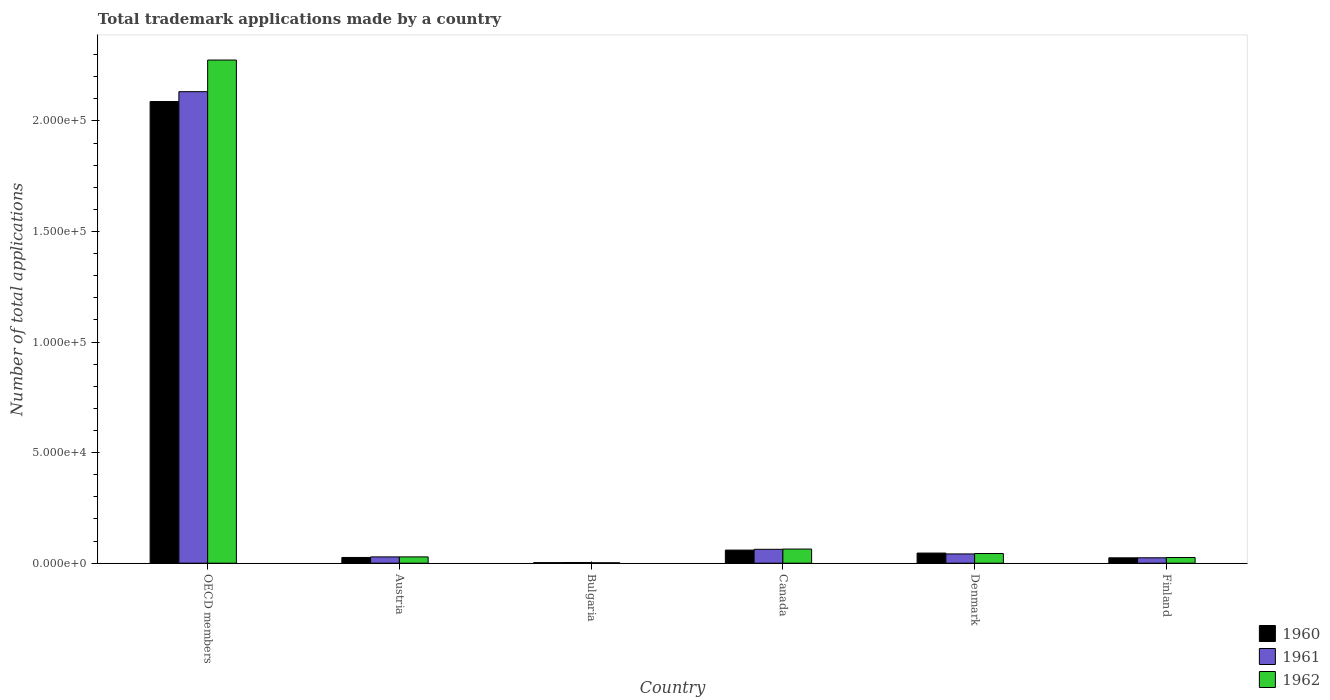How many different coloured bars are there?
Your response must be concise. 3. How many groups of bars are there?
Provide a short and direct response. 6. Are the number of bars per tick equal to the number of legend labels?
Your response must be concise. Yes. How many bars are there on the 6th tick from the left?
Provide a succinct answer. 3. What is the label of the 5th group of bars from the left?
Offer a very short reply. Denmark. What is the number of applications made by in 1962 in Finland?
Your answer should be compact. 2582. Across all countries, what is the maximum number of applications made by in 1962?
Give a very brief answer. 2.28e+05. Across all countries, what is the minimum number of applications made by in 1960?
Your answer should be very brief. 250. What is the total number of applications made by in 1961 in the graph?
Keep it short and to the point. 2.29e+05. What is the difference between the number of applications made by in 1962 in Austria and that in Finland?
Ensure brevity in your answer.  267. What is the difference between the number of applications made by in 1960 in Bulgaria and the number of applications made by in 1961 in Canada?
Give a very brief answer. -6031. What is the average number of applications made by in 1961 per country?
Provide a short and direct response. 3.82e+04. What is the difference between the number of applications made by of/in 1962 and number of applications made by of/in 1960 in Austria?
Your response must be concise. 253. In how many countries, is the number of applications made by in 1962 greater than 120000?
Provide a succinct answer. 1. What is the ratio of the number of applications made by in 1962 in Austria to that in Canada?
Your answer should be compact. 0.45. Is the number of applications made by in 1961 in Denmark less than that in OECD members?
Provide a short and direct response. Yes. Is the difference between the number of applications made by in 1962 in Canada and Denmark greater than the difference between the number of applications made by in 1960 in Canada and Denmark?
Ensure brevity in your answer.  Yes. What is the difference between the highest and the second highest number of applications made by in 1961?
Provide a succinct answer. 2085. What is the difference between the highest and the lowest number of applications made by in 1961?
Offer a very short reply. 2.13e+05. In how many countries, is the number of applications made by in 1960 greater than the average number of applications made by in 1960 taken over all countries?
Offer a terse response. 1. What does the 2nd bar from the left in Finland represents?
Offer a terse response. 1961. What does the 3rd bar from the right in Canada represents?
Provide a succinct answer. 1960. Is it the case that in every country, the sum of the number of applications made by in 1960 and number of applications made by in 1962 is greater than the number of applications made by in 1961?
Give a very brief answer. Yes. How many bars are there?
Provide a short and direct response. 18. How many countries are there in the graph?
Offer a terse response. 6. Does the graph contain any zero values?
Ensure brevity in your answer.  No. Where does the legend appear in the graph?
Your answer should be compact. Bottom right. How are the legend labels stacked?
Keep it short and to the point. Vertical. What is the title of the graph?
Provide a succinct answer. Total trademark applications made by a country. Does "1998" appear as one of the legend labels in the graph?
Offer a terse response. No. What is the label or title of the Y-axis?
Offer a very short reply. Number of total applications. What is the Number of total applications of 1960 in OECD members?
Offer a very short reply. 2.09e+05. What is the Number of total applications in 1961 in OECD members?
Ensure brevity in your answer.  2.13e+05. What is the Number of total applications in 1962 in OECD members?
Your answer should be compact. 2.28e+05. What is the Number of total applications in 1960 in Austria?
Your answer should be compact. 2596. What is the Number of total applications of 1961 in Austria?
Provide a short and direct response. 2852. What is the Number of total applications of 1962 in Austria?
Offer a terse response. 2849. What is the Number of total applications of 1960 in Bulgaria?
Your answer should be very brief. 250. What is the Number of total applications in 1961 in Bulgaria?
Your response must be concise. 318. What is the Number of total applications of 1962 in Bulgaria?
Ensure brevity in your answer.  195. What is the Number of total applications in 1960 in Canada?
Provide a short and direct response. 5927. What is the Number of total applications of 1961 in Canada?
Offer a terse response. 6281. What is the Number of total applications in 1962 in Canada?
Provide a succinct answer. 6395. What is the Number of total applications in 1960 in Denmark?
Offer a very short reply. 4584. What is the Number of total applications in 1961 in Denmark?
Provide a short and direct response. 4196. What is the Number of total applications in 1962 in Denmark?
Offer a terse response. 4380. What is the Number of total applications in 1960 in Finland?
Provide a short and direct response. 2432. What is the Number of total applications in 1961 in Finland?
Your response must be concise. 2450. What is the Number of total applications of 1962 in Finland?
Your answer should be compact. 2582. Across all countries, what is the maximum Number of total applications in 1960?
Your response must be concise. 2.09e+05. Across all countries, what is the maximum Number of total applications in 1961?
Provide a short and direct response. 2.13e+05. Across all countries, what is the maximum Number of total applications in 1962?
Keep it short and to the point. 2.28e+05. Across all countries, what is the minimum Number of total applications of 1960?
Your response must be concise. 250. Across all countries, what is the minimum Number of total applications in 1961?
Provide a short and direct response. 318. Across all countries, what is the minimum Number of total applications of 1962?
Your answer should be compact. 195. What is the total Number of total applications of 1960 in the graph?
Offer a terse response. 2.25e+05. What is the total Number of total applications of 1961 in the graph?
Offer a very short reply. 2.29e+05. What is the total Number of total applications in 1962 in the graph?
Provide a succinct answer. 2.44e+05. What is the difference between the Number of total applications of 1960 in OECD members and that in Austria?
Give a very brief answer. 2.06e+05. What is the difference between the Number of total applications in 1961 in OECD members and that in Austria?
Offer a very short reply. 2.10e+05. What is the difference between the Number of total applications of 1962 in OECD members and that in Austria?
Make the answer very short. 2.25e+05. What is the difference between the Number of total applications in 1960 in OECD members and that in Bulgaria?
Give a very brief answer. 2.09e+05. What is the difference between the Number of total applications in 1961 in OECD members and that in Bulgaria?
Offer a terse response. 2.13e+05. What is the difference between the Number of total applications in 1962 in OECD members and that in Bulgaria?
Offer a very short reply. 2.27e+05. What is the difference between the Number of total applications of 1960 in OECD members and that in Canada?
Your answer should be compact. 2.03e+05. What is the difference between the Number of total applications of 1961 in OECD members and that in Canada?
Ensure brevity in your answer.  2.07e+05. What is the difference between the Number of total applications in 1962 in OECD members and that in Canada?
Your answer should be very brief. 2.21e+05. What is the difference between the Number of total applications in 1960 in OECD members and that in Denmark?
Provide a succinct answer. 2.04e+05. What is the difference between the Number of total applications in 1961 in OECD members and that in Denmark?
Provide a short and direct response. 2.09e+05. What is the difference between the Number of total applications in 1962 in OECD members and that in Denmark?
Ensure brevity in your answer.  2.23e+05. What is the difference between the Number of total applications of 1960 in OECD members and that in Finland?
Keep it short and to the point. 2.06e+05. What is the difference between the Number of total applications of 1961 in OECD members and that in Finland?
Your response must be concise. 2.11e+05. What is the difference between the Number of total applications of 1962 in OECD members and that in Finland?
Offer a very short reply. 2.25e+05. What is the difference between the Number of total applications in 1960 in Austria and that in Bulgaria?
Offer a very short reply. 2346. What is the difference between the Number of total applications of 1961 in Austria and that in Bulgaria?
Ensure brevity in your answer.  2534. What is the difference between the Number of total applications of 1962 in Austria and that in Bulgaria?
Make the answer very short. 2654. What is the difference between the Number of total applications in 1960 in Austria and that in Canada?
Ensure brevity in your answer.  -3331. What is the difference between the Number of total applications in 1961 in Austria and that in Canada?
Ensure brevity in your answer.  -3429. What is the difference between the Number of total applications in 1962 in Austria and that in Canada?
Keep it short and to the point. -3546. What is the difference between the Number of total applications in 1960 in Austria and that in Denmark?
Provide a short and direct response. -1988. What is the difference between the Number of total applications in 1961 in Austria and that in Denmark?
Ensure brevity in your answer.  -1344. What is the difference between the Number of total applications in 1962 in Austria and that in Denmark?
Offer a very short reply. -1531. What is the difference between the Number of total applications in 1960 in Austria and that in Finland?
Offer a terse response. 164. What is the difference between the Number of total applications in 1961 in Austria and that in Finland?
Provide a succinct answer. 402. What is the difference between the Number of total applications in 1962 in Austria and that in Finland?
Your answer should be very brief. 267. What is the difference between the Number of total applications in 1960 in Bulgaria and that in Canada?
Provide a short and direct response. -5677. What is the difference between the Number of total applications of 1961 in Bulgaria and that in Canada?
Provide a succinct answer. -5963. What is the difference between the Number of total applications in 1962 in Bulgaria and that in Canada?
Provide a succinct answer. -6200. What is the difference between the Number of total applications in 1960 in Bulgaria and that in Denmark?
Make the answer very short. -4334. What is the difference between the Number of total applications in 1961 in Bulgaria and that in Denmark?
Provide a short and direct response. -3878. What is the difference between the Number of total applications of 1962 in Bulgaria and that in Denmark?
Provide a short and direct response. -4185. What is the difference between the Number of total applications of 1960 in Bulgaria and that in Finland?
Provide a short and direct response. -2182. What is the difference between the Number of total applications in 1961 in Bulgaria and that in Finland?
Make the answer very short. -2132. What is the difference between the Number of total applications in 1962 in Bulgaria and that in Finland?
Your answer should be compact. -2387. What is the difference between the Number of total applications in 1960 in Canada and that in Denmark?
Give a very brief answer. 1343. What is the difference between the Number of total applications in 1961 in Canada and that in Denmark?
Make the answer very short. 2085. What is the difference between the Number of total applications of 1962 in Canada and that in Denmark?
Provide a succinct answer. 2015. What is the difference between the Number of total applications in 1960 in Canada and that in Finland?
Provide a succinct answer. 3495. What is the difference between the Number of total applications in 1961 in Canada and that in Finland?
Make the answer very short. 3831. What is the difference between the Number of total applications in 1962 in Canada and that in Finland?
Make the answer very short. 3813. What is the difference between the Number of total applications in 1960 in Denmark and that in Finland?
Give a very brief answer. 2152. What is the difference between the Number of total applications in 1961 in Denmark and that in Finland?
Provide a succinct answer. 1746. What is the difference between the Number of total applications of 1962 in Denmark and that in Finland?
Ensure brevity in your answer.  1798. What is the difference between the Number of total applications of 1960 in OECD members and the Number of total applications of 1961 in Austria?
Your response must be concise. 2.06e+05. What is the difference between the Number of total applications in 1960 in OECD members and the Number of total applications in 1962 in Austria?
Ensure brevity in your answer.  2.06e+05. What is the difference between the Number of total applications of 1961 in OECD members and the Number of total applications of 1962 in Austria?
Your response must be concise. 2.10e+05. What is the difference between the Number of total applications of 1960 in OECD members and the Number of total applications of 1961 in Bulgaria?
Offer a very short reply. 2.08e+05. What is the difference between the Number of total applications of 1960 in OECD members and the Number of total applications of 1962 in Bulgaria?
Offer a terse response. 2.09e+05. What is the difference between the Number of total applications of 1961 in OECD members and the Number of total applications of 1962 in Bulgaria?
Provide a short and direct response. 2.13e+05. What is the difference between the Number of total applications of 1960 in OECD members and the Number of total applications of 1961 in Canada?
Your answer should be very brief. 2.02e+05. What is the difference between the Number of total applications of 1960 in OECD members and the Number of total applications of 1962 in Canada?
Provide a succinct answer. 2.02e+05. What is the difference between the Number of total applications of 1961 in OECD members and the Number of total applications of 1962 in Canada?
Offer a terse response. 2.07e+05. What is the difference between the Number of total applications of 1960 in OECD members and the Number of total applications of 1961 in Denmark?
Provide a short and direct response. 2.05e+05. What is the difference between the Number of total applications of 1960 in OECD members and the Number of total applications of 1962 in Denmark?
Keep it short and to the point. 2.04e+05. What is the difference between the Number of total applications in 1961 in OECD members and the Number of total applications in 1962 in Denmark?
Offer a terse response. 2.09e+05. What is the difference between the Number of total applications in 1960 in OECD members and the Number of total applications in 1961 in Finland?
Give a very brief answer. 2.06e+05. What is the difference between the Number of total applications in 1960 in OECD members and the Number of total applications in 1962 in Finland?
Offer a terse response. 2.06e+05. What is the difference between the Number of total applications of 1961 in OECD members and the Number of total applications of 1962 in Finland?
Keep it short and to the point. 2.11e+05. What is the difference between the Number of total applications of 1960 in Austria and the Number of total applications of 1961 in Bulgaria?
Offer a terse response. 2278. What is the difference between the Number of total applications in 1960 in Austria and the Number of total applications in 1962 in Bulgaria?
Make the answer very short. 2401. What is the difference between the Number of total applications of 1961 in Austria and the Number of total applications of 1962 in Bulgaria?
Offer a very short reply. 2657. What is the difference between the Number of total applications of 1960 in Austria and the Number of total applications of 1961 in Canada?
Your answer should be very brief. -3685. What is the difference between the Number of total applications of 1960 in Austria and the Number of total applications of 1962 in Canada?
Ensure brevity in your answer.  -3799. What is the difference between the Number of total applications in 1961 in Austria and the Number of total applications in 1962 in Canada?
Provide a succinct answer. -3543. What is the difference between the Number of total applications of 1960 in Austria and the Number of total applications of 1961 in Denmark?
Keep it short and to the point. -1600. What is the difference between the Number of total applications in 1960 in Austria and the Number of total applications in 1962 in Denmark?
Keep it short and to the point. -1784. What is the difference between the Number of total applications of 1961 in Austria and the Number of total applications of 1962 in Denmark?
Keep it short and to the point. -1528. What is the difference between the Number of total applications of 1960 in Austria and the Number of total applications of 1961 in Finland?
Provide a succinct answer. 146. What is the difference between the Number of total applications of 1961 in Austria and the Number of total applications of 1962 in Finland?
Offer a terse response. 270. What is the difference between the Number of total applications of 1960 in Bulgaria and the Number of total applications of 1961 in Canada?
Your answer should be compact. -6031. What is the difference between the Number of total applications of 1960 in Bulgaria and the Number of total applications of 1962 in Canada?
Provide a succinct answer. -6145. What is the difference between the Number of total applications in 1961 in Bulgaria and the Number of total applications in 1962 in Canada?
Offer a terse response. -6077. What is the difference between the Number of total applications in 1960 in Bulgaria and the Number of total applications in 1961 in Denmark?
Give a very brief answer. -3946. What is the difference between the Number of total applications in 1960 in Bulgaria and the Number of total applications in 1962 in Denmark?
Offer a terse response. -4130. What is the difference between the Number of total applications in 1961 in Bulgaria and the Number of total applications in 1962 in Denmark?
Offer a very short reply. -4062. What is the difference between the Number of total applications of 1960 in Bulgaria and the Number of total applications of 1961 in Finland?
Provide a succinct answer. -2200. What is the difference between the Number of total applications in 1960 in Bulgaria and the Number of total applications in 1962 in Finland?
Give a very brief answer. -2332. What is the difference between the Number of total applications in 1961 in Bulgaria and the Number of total applications in 1962 in Finland?
Your answer should be very brief. -2264. What is the difference between the Number of total applications of 1960 in Canada and the Number of total applications of 1961 in Denmark?
Your response must be concise. 1731. What is the difference between the Number of total applications in 1960 in Canada and the Number of total applications in 1962 in Denmark?
Your answer should be compact. 1547. What is the difference between the Number of total applications of 1961 in Canada and the Number of total applications of 1962 in Denmark?
Keep it short and to the point. 1901. What is the difference between the Number of total applications in 1960 in Canada and the Number of total applications in 1961 in Finland?
Keep it short and to the point. 3477. What is the difference between the Number of total applications of 1960 in Canada and the Number of total applications of 1962 in Finland?
Give a very brief answer. 3345. What is the difference between the Number of total applications in 1961 in Canada and the Number of total applications in 1962 in Finland?
Your answer should be very brief. 3699. What is the difference between the Number of total applications in 1960 in Denmark and the Number of total applications in 1961 in Finland?
Offer a very short reply. 2134. What is the difference between the Number of total applications in 1960 in Denmark and the Number of total applications in 1962 in Finland?
Provide a succinct answer. 2002. What is the difference between the Number of total applications in 1961 in Denmark and the Number of total applications in 1962 in Finland?
Give a very brief answer. 1614. What is the average Number of total applications of 1960 per country?
Ensure brevity in your answer.  3.74e+04. What is the average Number of total applications of 1961 per country?
Your answer should be compact. 3.82e+04. What is the average Number of total applications in 1962 per country?
Offer a terse response. 4.07e+04. What is the difference between the Number of total applications in 1960 and Number of total applications in 1961 in OECD members?
Your response must be concise. -4452. What is the difference between the Number of total applications in 1960 and Number of total applications in 1962 in OECD members?
Provide a short and direct response. -1.88e+04. What is the difference between the Number of total applications of 1961 and Number of total applications of 1962 in OECD members?
Ensure brevity in your answer.  -1.43e+04. What is the difference between the Number of total applications in 1960 and Number of total applications in 1961 in Austria?
Ensure brevity in your answer.  -256. What is the difference between the Number of total applications of 1960 and Number of total applications of 1962 in Austria?
Provide a short and direct response. -253. What is the difference between the Number of total applications of 1960 and Number of total applications of 1961 in Bulgaria?
Ensure brevity in your answer.  -68. What is the difference between the Number of total applications of 1960 and Number of total applications of 1962 in Bulgaria?
Provide a short and direct response. 55. What is the difference between the Number of total applications of 1961 and Number of total applications of 1962 in Bulgaria?
Offer a very short reply. 123. What is the difference between the Number of total applications in 1960 and Number of total applications in 1961 in Canada?
Your response must be concise. -354. What is the difference between the Number of total applications of 1960 and Number of total applications of 1962 in Canada?
Your response must be concise. -468. What is the difference between the Number of total applications in 1961 and Number of total applications in 1962 in Canada?
Offer a very short reply. -114. What is the difference between the Number of total applications in 1960 and Number of total applications in 1961 in Denmark?
Offer a very short reply. 388. What is the difference between the Number of total applications of 1960 and Number of total applications of 1962 in Denmark?
Make the answer very short. 204. What is the difference between the Number of total applications of 1961 and Number of total applications of 1962 in Denmark?
Keep it short and to the point. -184. What is the difference between the Number of total applications in 1960 and Number of total applications in 1961 in Finland?
Offer a terse response. -18. What is the difference between the Number of total applications in 1960 and Number of total applications in 1962 in Finland?
Make the answer very short. -150. What is the difference between the Number of total applications in 1961 and Number of total applications in 1962 in Finland?
Offer a very short reply. -132. What is the ratio of the Number of total applications of 1960 in OECD members to that in Austria?
Ensure brevity in your answer.  80.42. What is the ratio of the Number of total applications in 1961 in OECD members to that in Austria?
Ensure brevity in your answer.  74.76. What is the ratio of the Number of total applications in 1962 in OECD members to that in Austria?
Provide a short and direct response. 79.86. What is the ratio of the Number of total applications of 1960 in OECD members to that in Bulgaria?
Your answer should be very brief. 835.08. What is the ratio of the Number of total applications of 1961 in OECD members to that in Bulgaria?
Your answer should be compact. 670.51. What is the ratio of the Number of total applications in 1962 in OECD members to that in Bulgaria?
Keep it short and to the point. 1166.82. What is the ratio of the Number of total applications of 1960 in OECD members to that in Canada?
Provide a succinct answer. 35.22. What is the ratio of the Number of total applications of 1961 in OECD members to that in Canada?
Offer a very short reply. 33.95. What is the ratio of the Number of total applications in 1962 in OECD members to that in Canada?
Give a very brief answer. 35.58. What is the ratio of the Number of total applications of 1960 in OECD members to that in Denmark?
Keep it short and to the point. 45.54. What is the ratio of the Number of total applications in 1961 in OECD members to that in Denmark?
Ensure brevity in your answer.  50.82. What is the ratio of the Number of total applications in 1962 in OECD members to that in Denmark?
Your answer should be compact. 51.95. What is the ratio of the Number of total applications in 1960 in OECD members to that in Finland?
Your answer should be compact. 85.84. What is the ratio of the Number of total applications of 1961 in OECD members to that in Finland?
Your answer should be compact. 87.03. What is the ratio of the Number of total applications of 1962 in OECD members to that in Finland?
Your answer should be compact. 88.12. What is the ratio of the Number of total applications in 1960 in Austria to that in Bulgaria?
Offer a very short reply. 10.38. What is the ratio of the Number of total applications of 1961 in Austria to that in Bulgaria?
Give a very brief answer. 8.97. What is the ratio of the Number of total applications of 1962 in Austria to that in Bulgaria?
Keep it short and to the point. 14.61. What is the ratio of the Number of total applications in 1960 in Austria to that in Canada?
Provide a succinct answer. 0.44. What is the ratio of the Number of total applications in 1961 in Austria to that in Canada?
Provide a short and direct response. 0.45. What is the ratio of the Number of total applications in 1962 in Austria to that in Canada?
Make the answer very short. 0.45. What is the ratio of the Number of total applications in 1960 in Austria to that in Denmark?
Offer a very short reply. 0.57. What is the ratio of the Number of total applications of 1961 in Austria to that in Denmark?
Provide a succinct answer. 0.68. What is the ratio of the Number of total applications of 1962 in Austria to that in Denmark?
Keep it short and to the point. 0.65. What is the ratio of the Number of total applications in 1960 in Austria to that in Finland?
Make the answer very short. 1.07. What is the ratio of the Number of total applications in 1961 in Austria to that in Finland?
Offer a very short reply. 1.16. What is the ratio of the Number of total applications of 1962 in Austria to that in Finland?
Offer a very short reply. 1.1. What is the ratio of the Number of total applications of 1960 in Bulgaria to that in Canada?
Your response must be concise. 0.04. What is the ratio of the Number of total applications in 1961 in Bulgaria to that in Canada?
Offer a terse response. 0.05. What is the ratio of the Number of total applications in 1962 in Bulgaria to that in Canada?
Your answer should be compact. 0.03. What is the ratio of the Number of total applications in 1960 in Bulgaria to that in Denmark?
Ensure brevity in your answer.  0.05. What is the ratio of the Number of total applications in 1961 in Bulgaria to that in Denmark?
Ensure brevity in your answer.  0.08. What is the ratio of the Number of total applications of 1962 in Bulgaria to that in Denmark?
Keep it short and to the point. 0.04. What is the ratio of the Number of total applications in 1960 in Bulgaria to that in Finland?
Make the answer very short. 0.1. What is the ratio of the Number of total applications of 1961 in Bulgaria to that in Finland?
Provide a succinct answer. 0.13. What is the ratio of the Number of total applications of 1962 in Bulgaria to that in Finland?
Your answer should be very brief. 0.08. What is the ratio of the Number of total applications in 1960 in Canada to that in Denmark?
Your response must be concise. 1.29. What is the ratio of the Number of total applications in 1961 in Canada to that in Denmark?
Make the answer very short. 1.5. What is the ratio of the Number of total applications of 1962 in Canada to that in Denmark?
Ensure brevity in your answer.  1.46. What is the ratio of the Number of total applications of 1960 in Canada to that in Finland?
Your response must be concise. 2.44. What is the ratio of the Number of total applications of 1961 in Canada to that in Finland?
Keep it short and to the point. 2.56. What is the ratio of the Number of total applications of 1962 in Canada to that in Finland?
Provide a short and direct response. 2.48. What is the ratio of the Number of total applications of 1960 in Denmark to that in Finland?
Give a very brief answer. 1.88. What is the ratio of the Number of total applications in 1961 in Denmark to that in Finland?
Your response must be concise. 1.71. What is the ratio of the Number of total applications in 1962 in Denmark to that in Finland?
Your answer should be compact. 1.7. What is the difference between the highest and the second highest Number of total applications in 1960?
Your response must be concise. 2.03e+05. What is the difference between the highest and the second highest Number of total applications in 1961?
Keep it short and to the point. 2.07e+05. What is the difference between the highest and the second highest Number of total applications of 1962?
Provide a short and direct response. 2.21e+05. What is the difference between the highest and the lowest Number of total applications of 1960?
Your answer should be compact. 2.09e+05. What is the difference between the highest and the lowest Number of total applications in 1961?
Make the answer very short. 2.13e+05. What is the difference between the highest and the lowest Number of total applications in 1962?
Your answer should be very brief. 2.27e+05. 